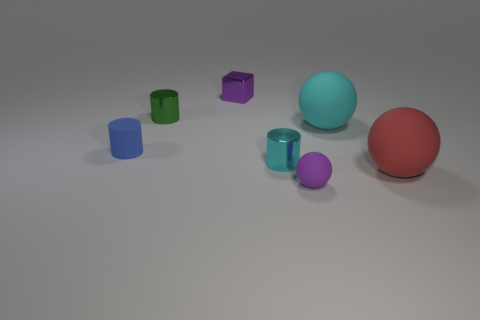Add 3 small rubber cylinders. How many objects exist? 10 Subtract all cubes. How many objects are left? 6 Subtract 0 gray balls. How many objects are left? 7 Subtract all purple metal spheres. Subtract all tiny blocks. How many objects are left? 6 Add 6 big red rubber balls. How many big red rubber balls are left? 7 Add 1 small cyan things. How many small cyan things exist? 2 